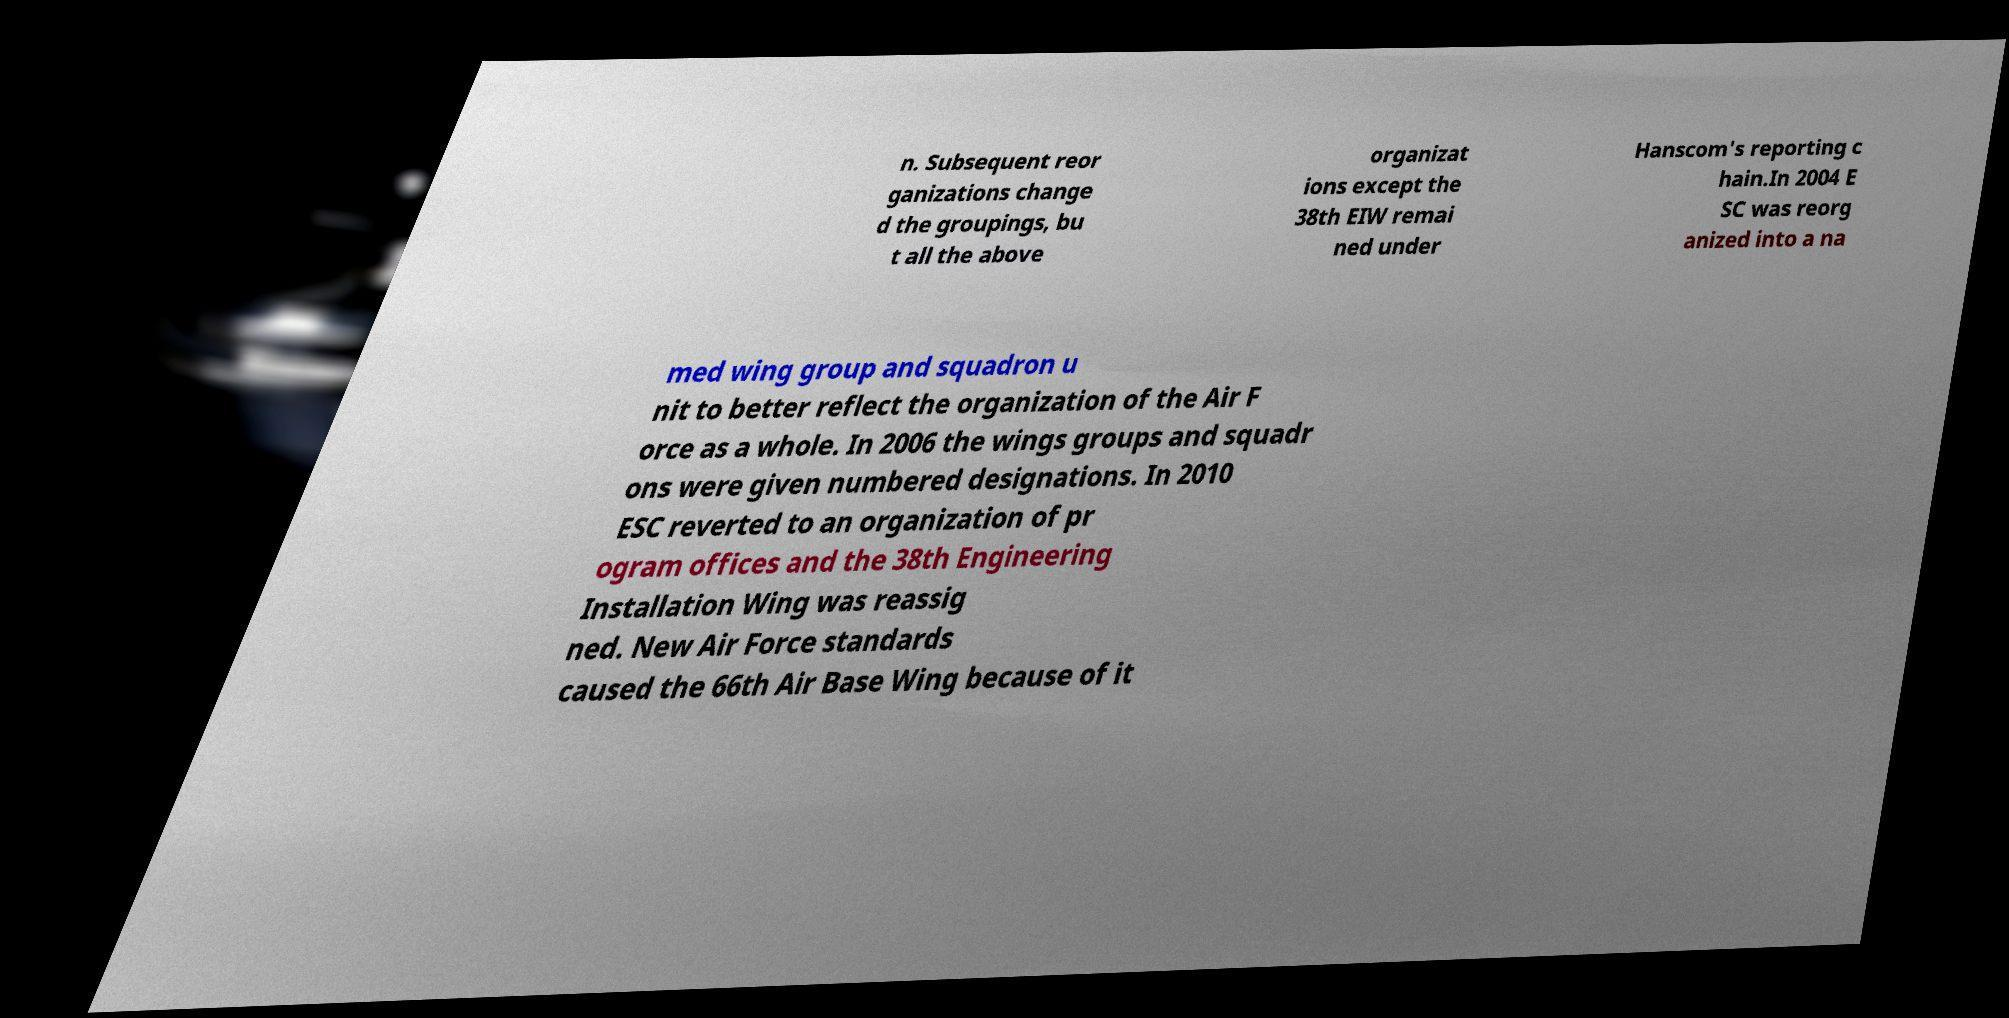For documentation purposes, I need the text within this image transcribed. Could you provide that? n. Subsequent reor ganizations change d the groupings, bu t all the above organizat ions except the 38th EIW remai ned under Hanscom's reporting c hain.In 2004 E SC was reorg anized into a na med wing group and squadron u nit to better reflect the organization of the Air F orce as a whole. In 2006 the wings groups and squadr ons were given numbered designations. In 2010 ESC reverted to an organization of pr ogram offices and the 38th Engineering Installation Wing was reassig ned. New Air Force standards caused the 66th Air Base Wing because of it 